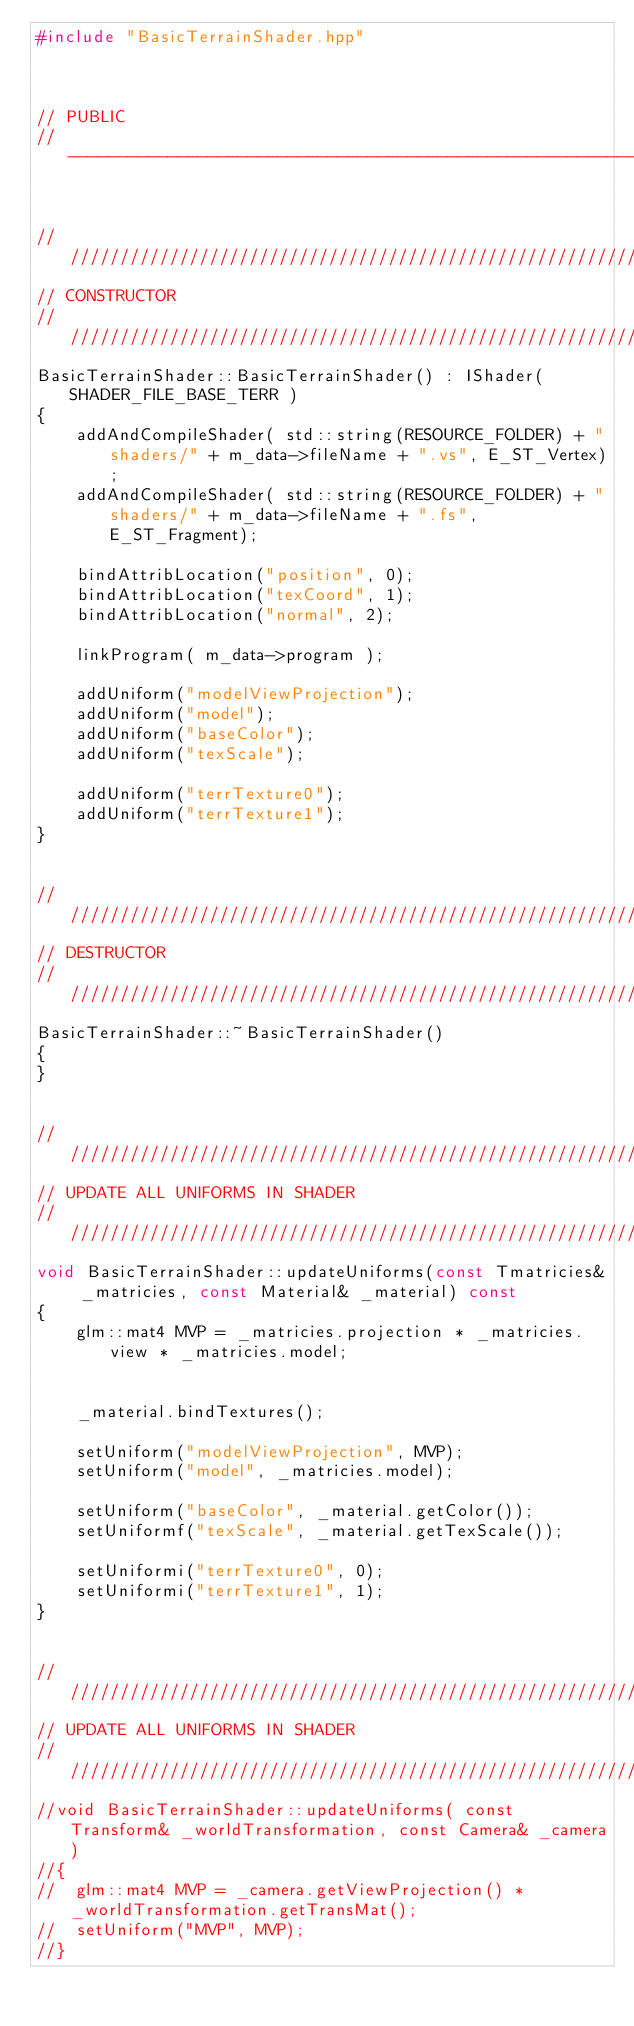Convert code to text. <code><loc_0><loc_0><loc_500><loc_500><_C++_>#include "BasicTerrainShader.hpp"



// PUBLIC
//------------------------------------------------------------------------------


////////////////////////////////////////////////////////////////////////////////
// CONSTRUCTOR
////////////////////////////////////////////////////////////////////////////////
BasicTerrainShader::BasicTerrainShader() : IShader( SHADER_FILE_BASE_TERR )
{
	addAndCompileShader( std::string(RESOURCE_FOLDER) + "shaders/" + m_data->fileName + ".vs", E_ST_Vertex);
	addAndCompileShader( std::string(RESOURCE_FOLDER) + "shaders/" + m_data->fileName + ".fs", E_ST_Fragment);

	bindAttribLocation("position", 0);
	bindAttribLocation("texCoord", 1);
	bindAttribLocation("normal", 2);

	linkProgram( m_data->program );

	addUniform("modelViewProjection");
	addUniform("model");
	addUniform("baseColor");
	addUniform("texScale");

	addUniform("terrTexture0");
	addUniform("terrTexture1");
}


////////////////////////////////////////////////////////////////////////////////
// DESTRUCTOR
////////////////////////////////////////////////////////////////////////////////
BasicTerrainShader::~BasicTerrainShader()
{
}


////////////////////////////////////////////////////////////////////////////////
// UPDATE ALL UNIFORMS IN SHADER
////////////////////////////////////////////////////////////////////////////////
void BasicTerrainShader::updateUniforms(const Tmatricies& _matricies, const Material& _material) const
{
	glm::mat4 MVP = _matricies.projection * _matricies.view * _matricies.model;


	_material.bindTextures();

	setUniform("modelViewProjection", MVP);
	setUniform("model", _matricies.model);

	setUniform("baseColor", _material.getColor());
	setUniformf("texScale", _material.getTexScale());

	setUniformi("terrTexture0", 0);
	setUniformi("terrTexture1", 1);
}


////////////////////////////////////////////////////////////////////////////////
// UPDATE ALL UNIFORMS IN SHADER
////////////////////////////////////////////////////////////////////////////////
//void BasicTerrainShader::updateUniforms( const Transform& _worldTransformation, const Camera& _camera)
//{
//	glm::mat4 MVP = _camera.getViewProjection() * _worldTransformation.getTransMat();
//	setUniform("MVP", MVP);
//}
</code> 